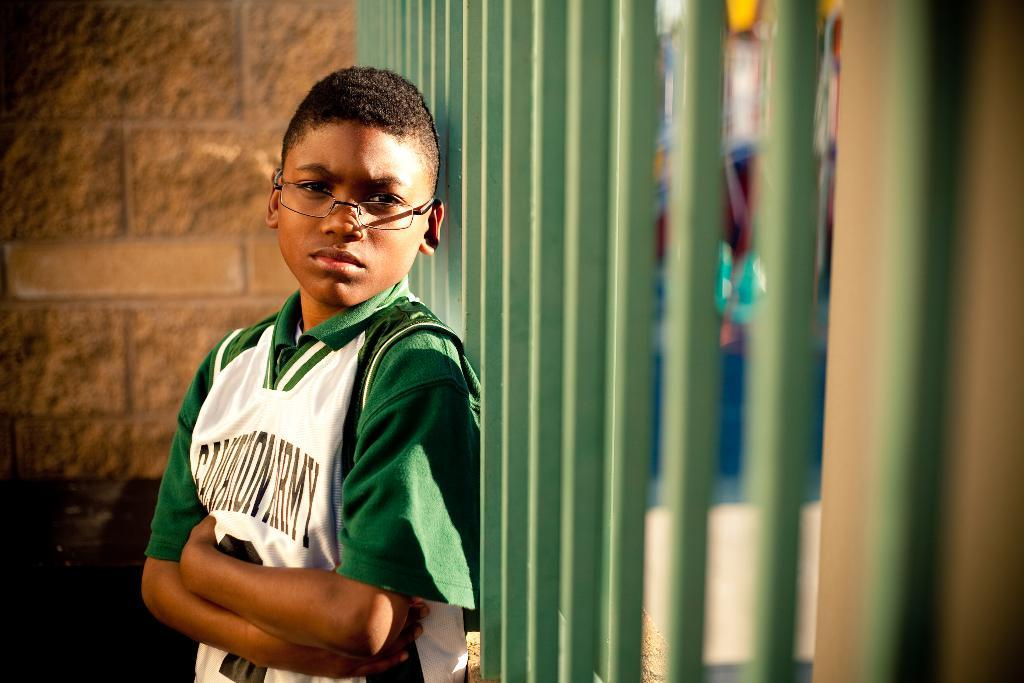Who is the main subject in the image? There is a boy in the image. What is the boy wearing? The boy is wearing specs. What can be seen in the background of the image? There is a wall in the background of the image. What is near the boy in the image? There is a railing with poles near the boy. How would you describe the background of the image? The background appears blurry. What type of book is the boy holding in the image? There is no book present in the image; the boy is not holding any object. What is the mass of the steel railing near the boy? There is no steel railing present in the image, so it is not possible to determine its mass. 